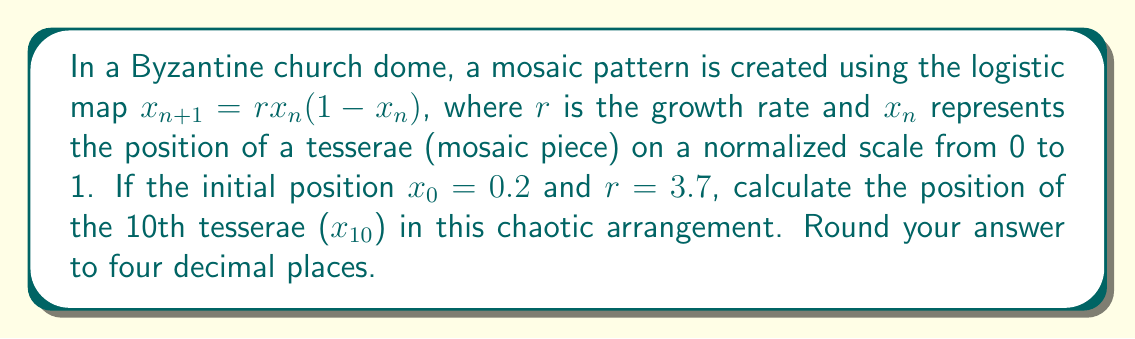Can you solve this math problem? To solve this problem, we need to iterate the logistic map equation 10 times, starting with $x_0 = 0.2$ and using $r = 3.7$. Let's go through this step-by-step:

1) First, let's recall the logistic map equation:
   $x_{n+1} = rx_n(1-x_n)$, where $r = 3.7$

2) Now, let's calculate each iteration:

   $x_1 = 3.7 \cdot 0.2 \cdot (1-0.2) = 0.592$
   
   $x_2 = 3.7 \cdot 0.592 \cdot (1-0.592) = 0.8929$
   
   $x_3 = 3.7 \cdot 0.8929 \cdot (1-0.8929) = 0.3542$
   
   $x_4 = 3.7 \cdot 0.3542 \cdot (1-0.3542) = 0.8455$
   
   $x_5 = 3.7 \cdot 0.8455 \cdot (1-0.8455) = 0.4827$
   
   $x_6 = 3.7 \cdot 0.4827 \cdot (1-0.4827) = 0.9236$
   
   $x_7 = 3.7 \cdot 0.9236 \cdot (1-0.9236) = 0.2615$
   
   $x_8 = 3.7 \cdot 0.2615 \cdot (1-0.2615) = 0.7150$
   
   $x_9 = 3.7 \cdot 0.7150 \cdot (1-0.7150) = 0.7553$
   
   $x_{10} = 3.7 \cdot 0.7553 \cdot (1-0.7553) = 0.6843$

3) Rounding $x_{10}$ to four decimal places gives us 0.6843.

This chaotic arrangement demonstrates how small changes in initial conditions can lead to vastly different outcomes, reflecting the intricate and seemingly random patterns often found in Byzantine mosaics.
Answer: 0.6843 